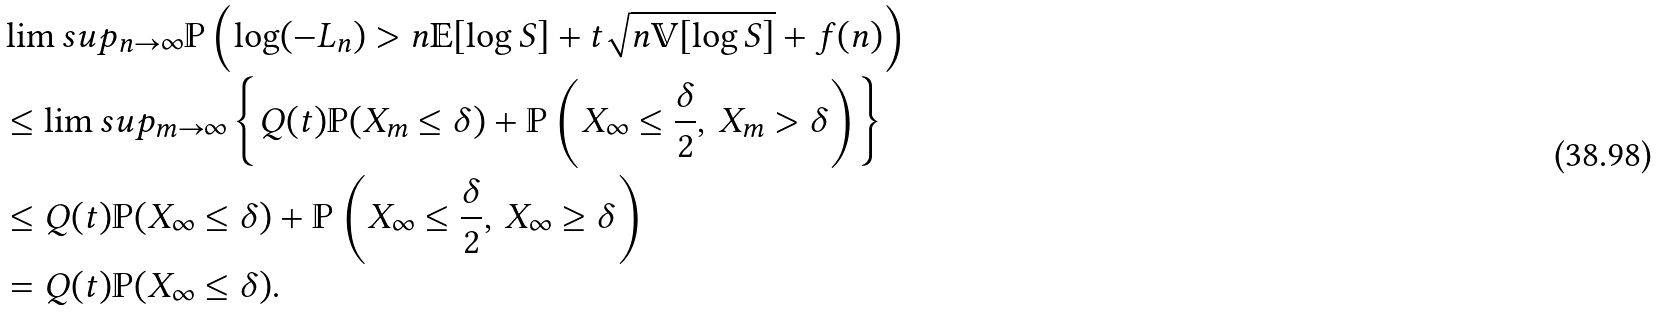<formula> <loc_0><loc_0><loc_500><loc_500>& \lim s u p _ { n \to \infty } \mathbb { P } \left ( \log ( - L _ { n } ) > n \mathbb { E } [ \log S ] + t \sqrt { n \mathbb { V } [ \log S ] } + f ( n ) \right ) \\ & \leq \lim s u p _ { m \to \infty } \left \{ Q ( t ) \mathbb { P } ( X _ { m } \leq \delta ) + \mathbb { P } \left ( X _ { \infty } \leq \frac { \delta } { 2 } , \, X _ { m } > \delta \right ) \right \} \\ & \leq Q ( t ) \mathbb { P } ( X _ { \infty } \leq \delta ) + \mathbb { P } \left ( X _ { \infty } \leq \frac { \delta } { 2 } , \, X _ { \infty } \geq \delta \right ) \\ & = Q ( t ) \mathbb { P } ( X _ { \infty } \leq \delta ) .</formula> 